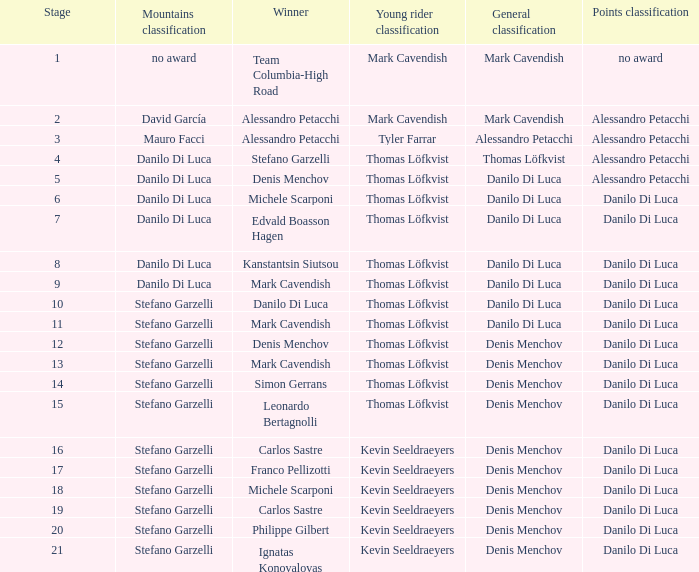When danilo di luca is the winner who is the general classification?  Danilo Di Luca. 